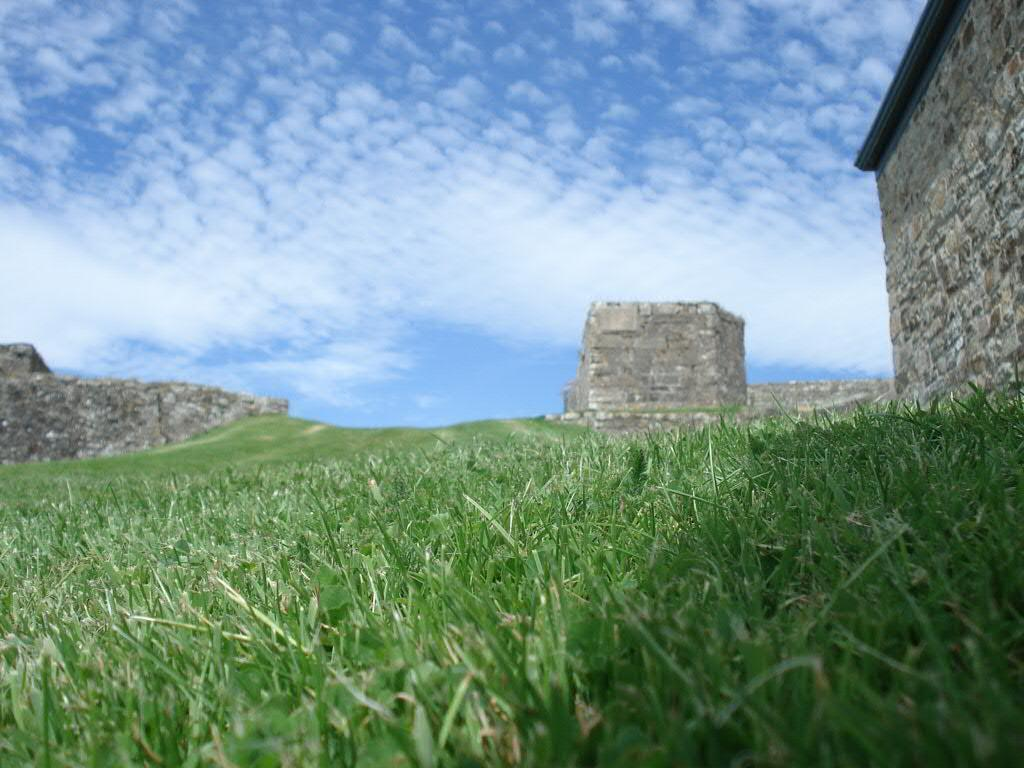What type of structure can be seen in the image? There are ruins in the image. What is the ground covered with in the image? There is green grass on the ground in the image. How would you describe the sky in the image? The sky is cloudy in the image. Can you hear the voice of the rat in the image? There is no rat or voice present in the image. 